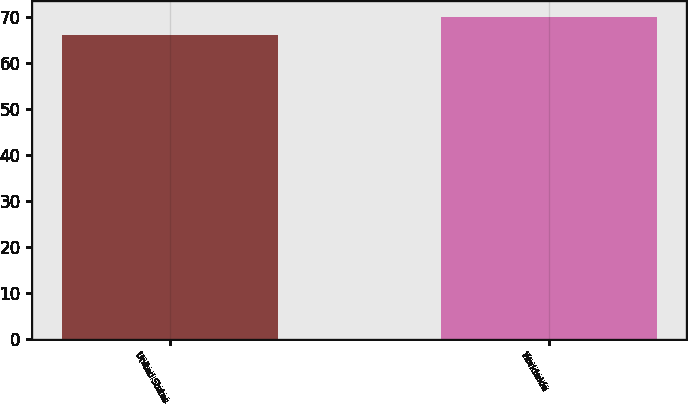Convert chart to OTSL. <chart><loc_0><loc_0><loc_500><loc_500><bar_chart><fcel>United States<fcel>Worldwide<nl><fcel>66<fcel>70<nl></chart> 